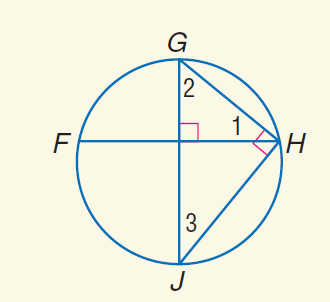Answer the mathemtical geometry problem and directly provide the correct option letter.
Question: m \widehat G H = 78. Find m \angle 1.
Choices: A: 39 B: 78 C: 98 D: 114 A 